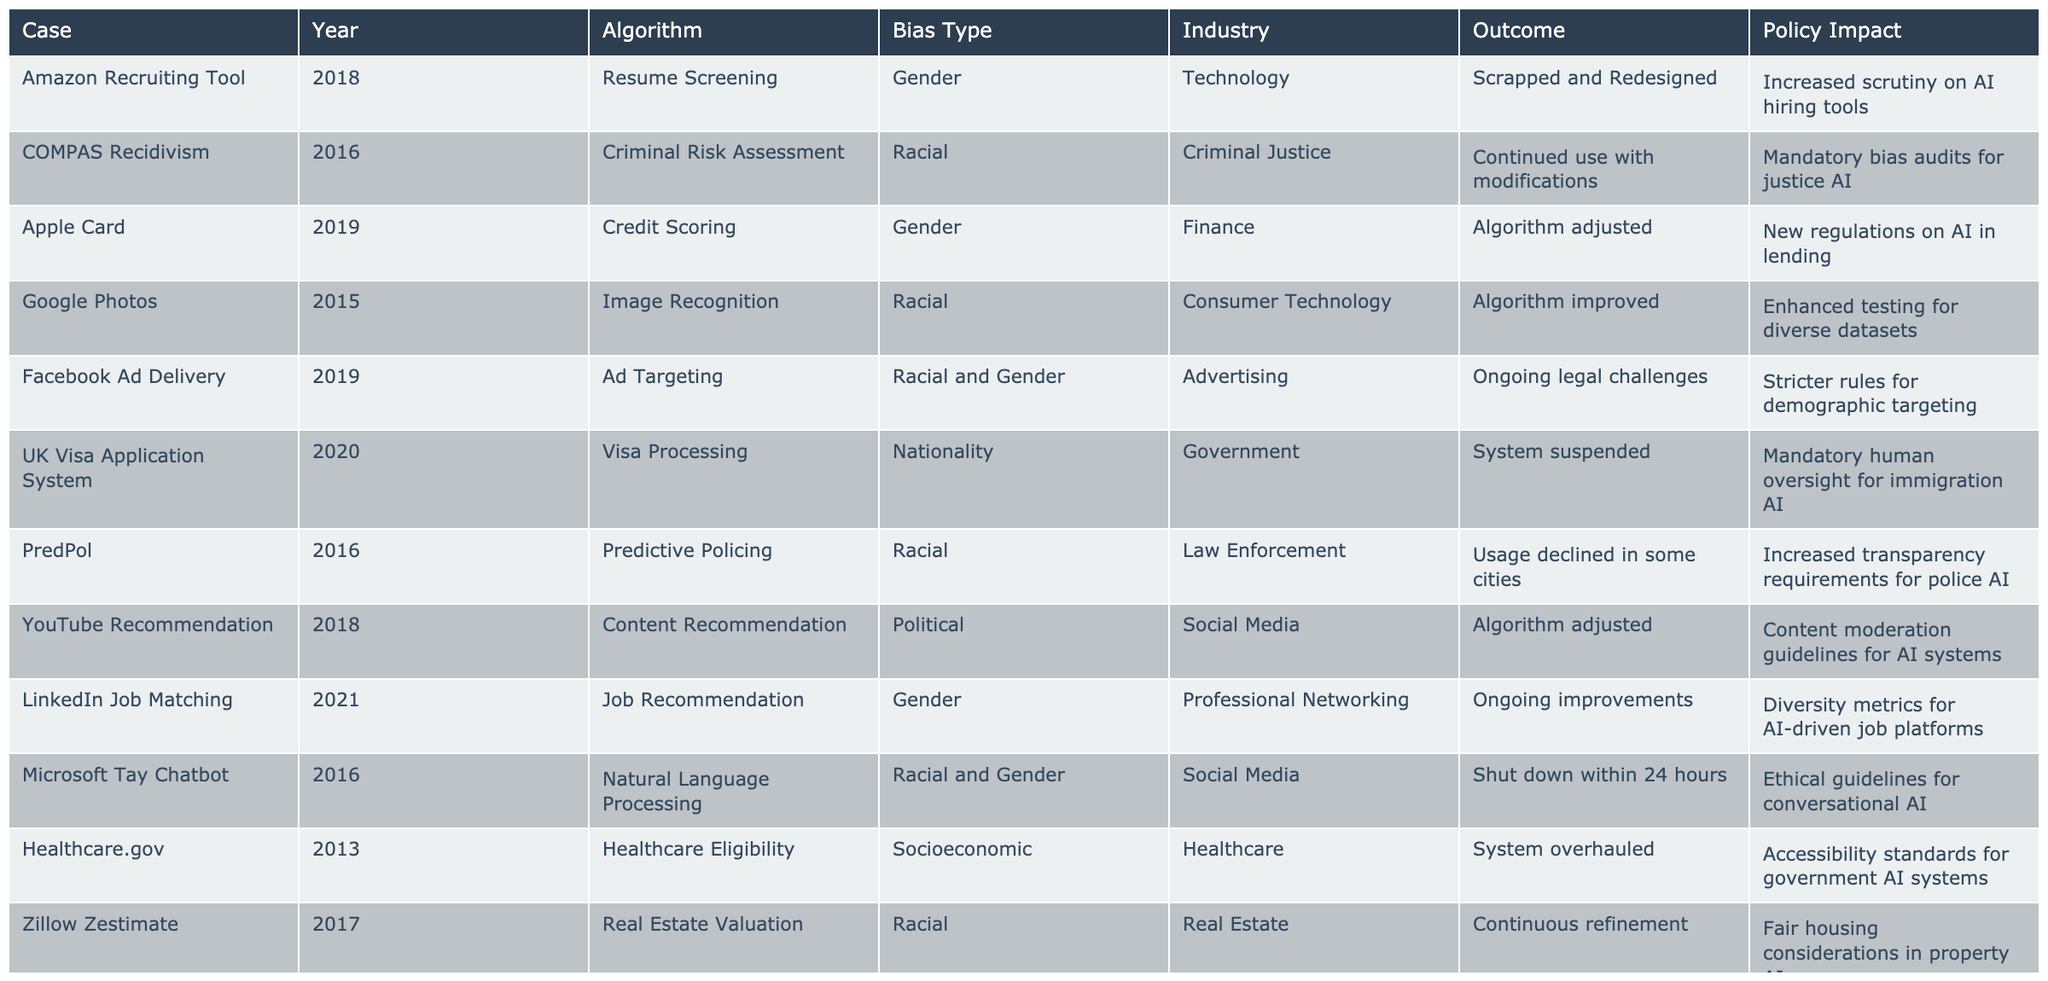What was the outcome of the Amazon Recruiting Tool case? The table states that the Amazon Recruiting Tool was scrapped and redesigned due to bias, indicating a complete overhaul of the algorithm used.
Answer: Scrapped and Redesigned Which bias type was involved in the COMPAS case? The table lists the bias type for the COMPAS Recidivism case as racial, indicating that the algorithm exhibited racial bias in its assessments.
Answer: Racial How many cases involved gender bias? By reviewing the table, we count 4 cases that involved gender bias: Amazon Recruiting Tool, Apple Card, LinkedIn Job Matching, and Microsoft Tay Chatbot.
Answer: 4 Did the UK Visa Application System result in mandatory human oversight? Yes, the table specifies that the outcome of the UK Visa Application System case included mandatory human oversight as a policy impact due to bias issues.
Answer: Yes What was the main policy impact of the Google Photos case? The table reveals that the outcome of the Google Photos case led to enhanced testing for diverse datasets, reflecting a policy focus on improving the algorithm's reliability across different racial groups.
Answer: Enhanced testing for diverse datasets In how many cases was the algorithm adjusted? The table shows that there were 4 cases where the algorithm was adjusted: Apple Card, YouTube Recommendation, Facebook Ad Delivery, and Amazon Recruiting Tool.
Answer: 4 Which industry had the highest occurrence of racial bias cases? By examining the table, we find that the Criminal Justice and Law Enforcement industries both feature 3 cases related to racial bias, making them the industries with the highest occurrences.
Answer: Criminal Justice and Law Enforcement Was there a case where the algorithm was shut down? Yes, the Microsoft Tay Chatbot case was shut down within 24 hours, as reflected in the table, indicating a swift response to the algorithm's bias issues.
Answer: Yes Which algorithm had the outcome of being banned in some jurisdictions? The Facial Recognition Systems case is listed in the table with the outcome of being banned in certain areas due to concerns about bias and privacy.
Answer: Facial Recognition Systems What was the outcome for the PredPol case in terms of usage? The table shows that usage of the PredPol algorithm declined in some cities, reflecting a growing awareness and response to the bias embedded in predictive policing.
Answer: Usage declined in some cities How many cases involved enhancements to guidelines or regulations as a policy impact? Counting the policy impacts related to enhancement, we find 4 cases: Healthcare.gov, Apple Card, YouTube Recommendation, and Google Photos.
Answer: 4 